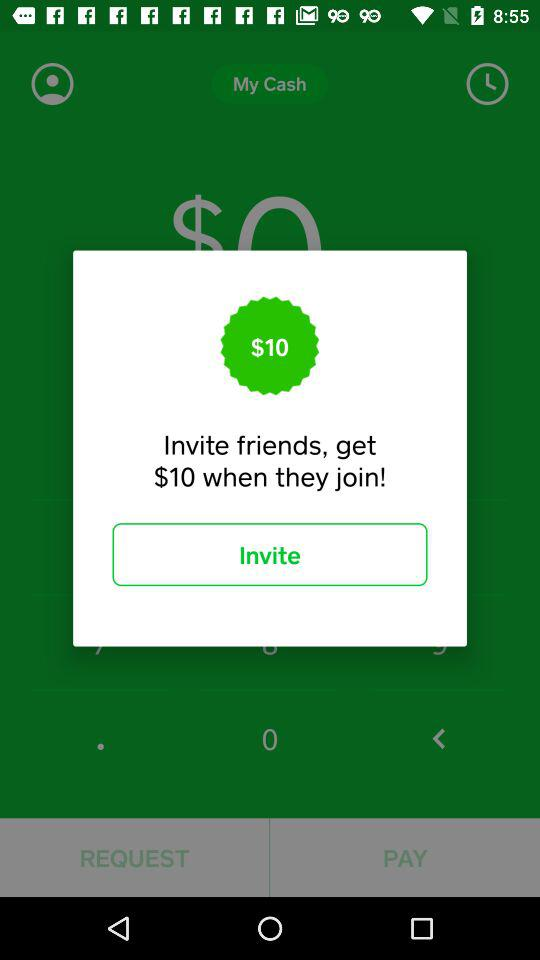What price do we get when a friend joins? You get $10 when a friend joins. 